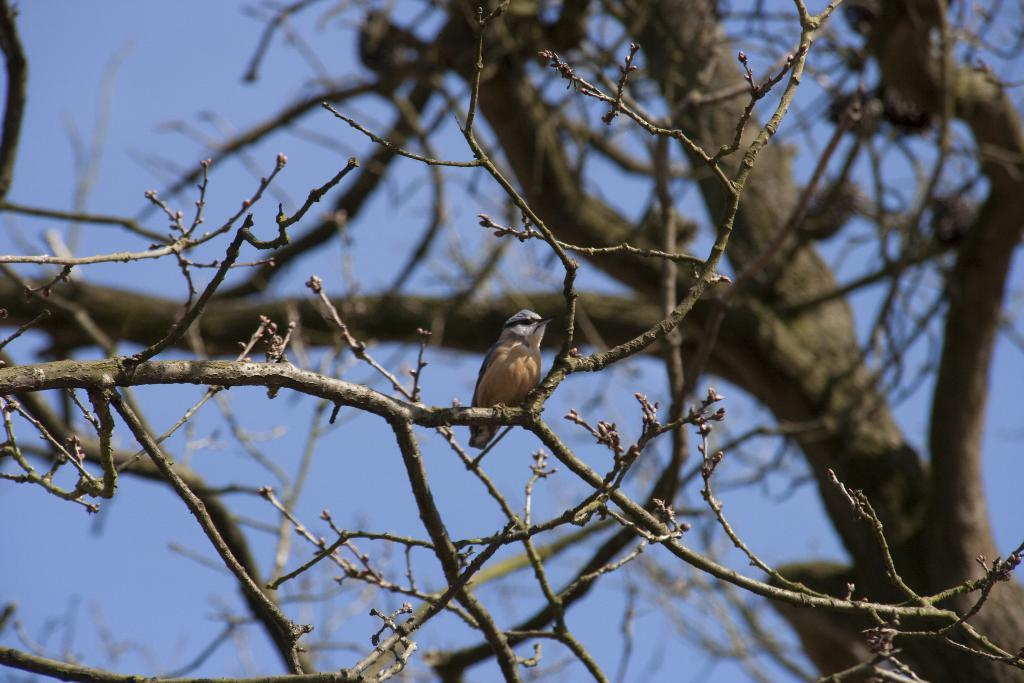What is the main object in the image? There is a tree in the image. Is there any wildlife present on the tree? Yes, there is a bird on the tree. What can be seen in the background of the image? The sky is visible in the background of the image. Where is the girl standing next to the basin in the image? There is no girl or basin present in the image. What type of train can be seen passing by in the image? There is no train present in the image. 